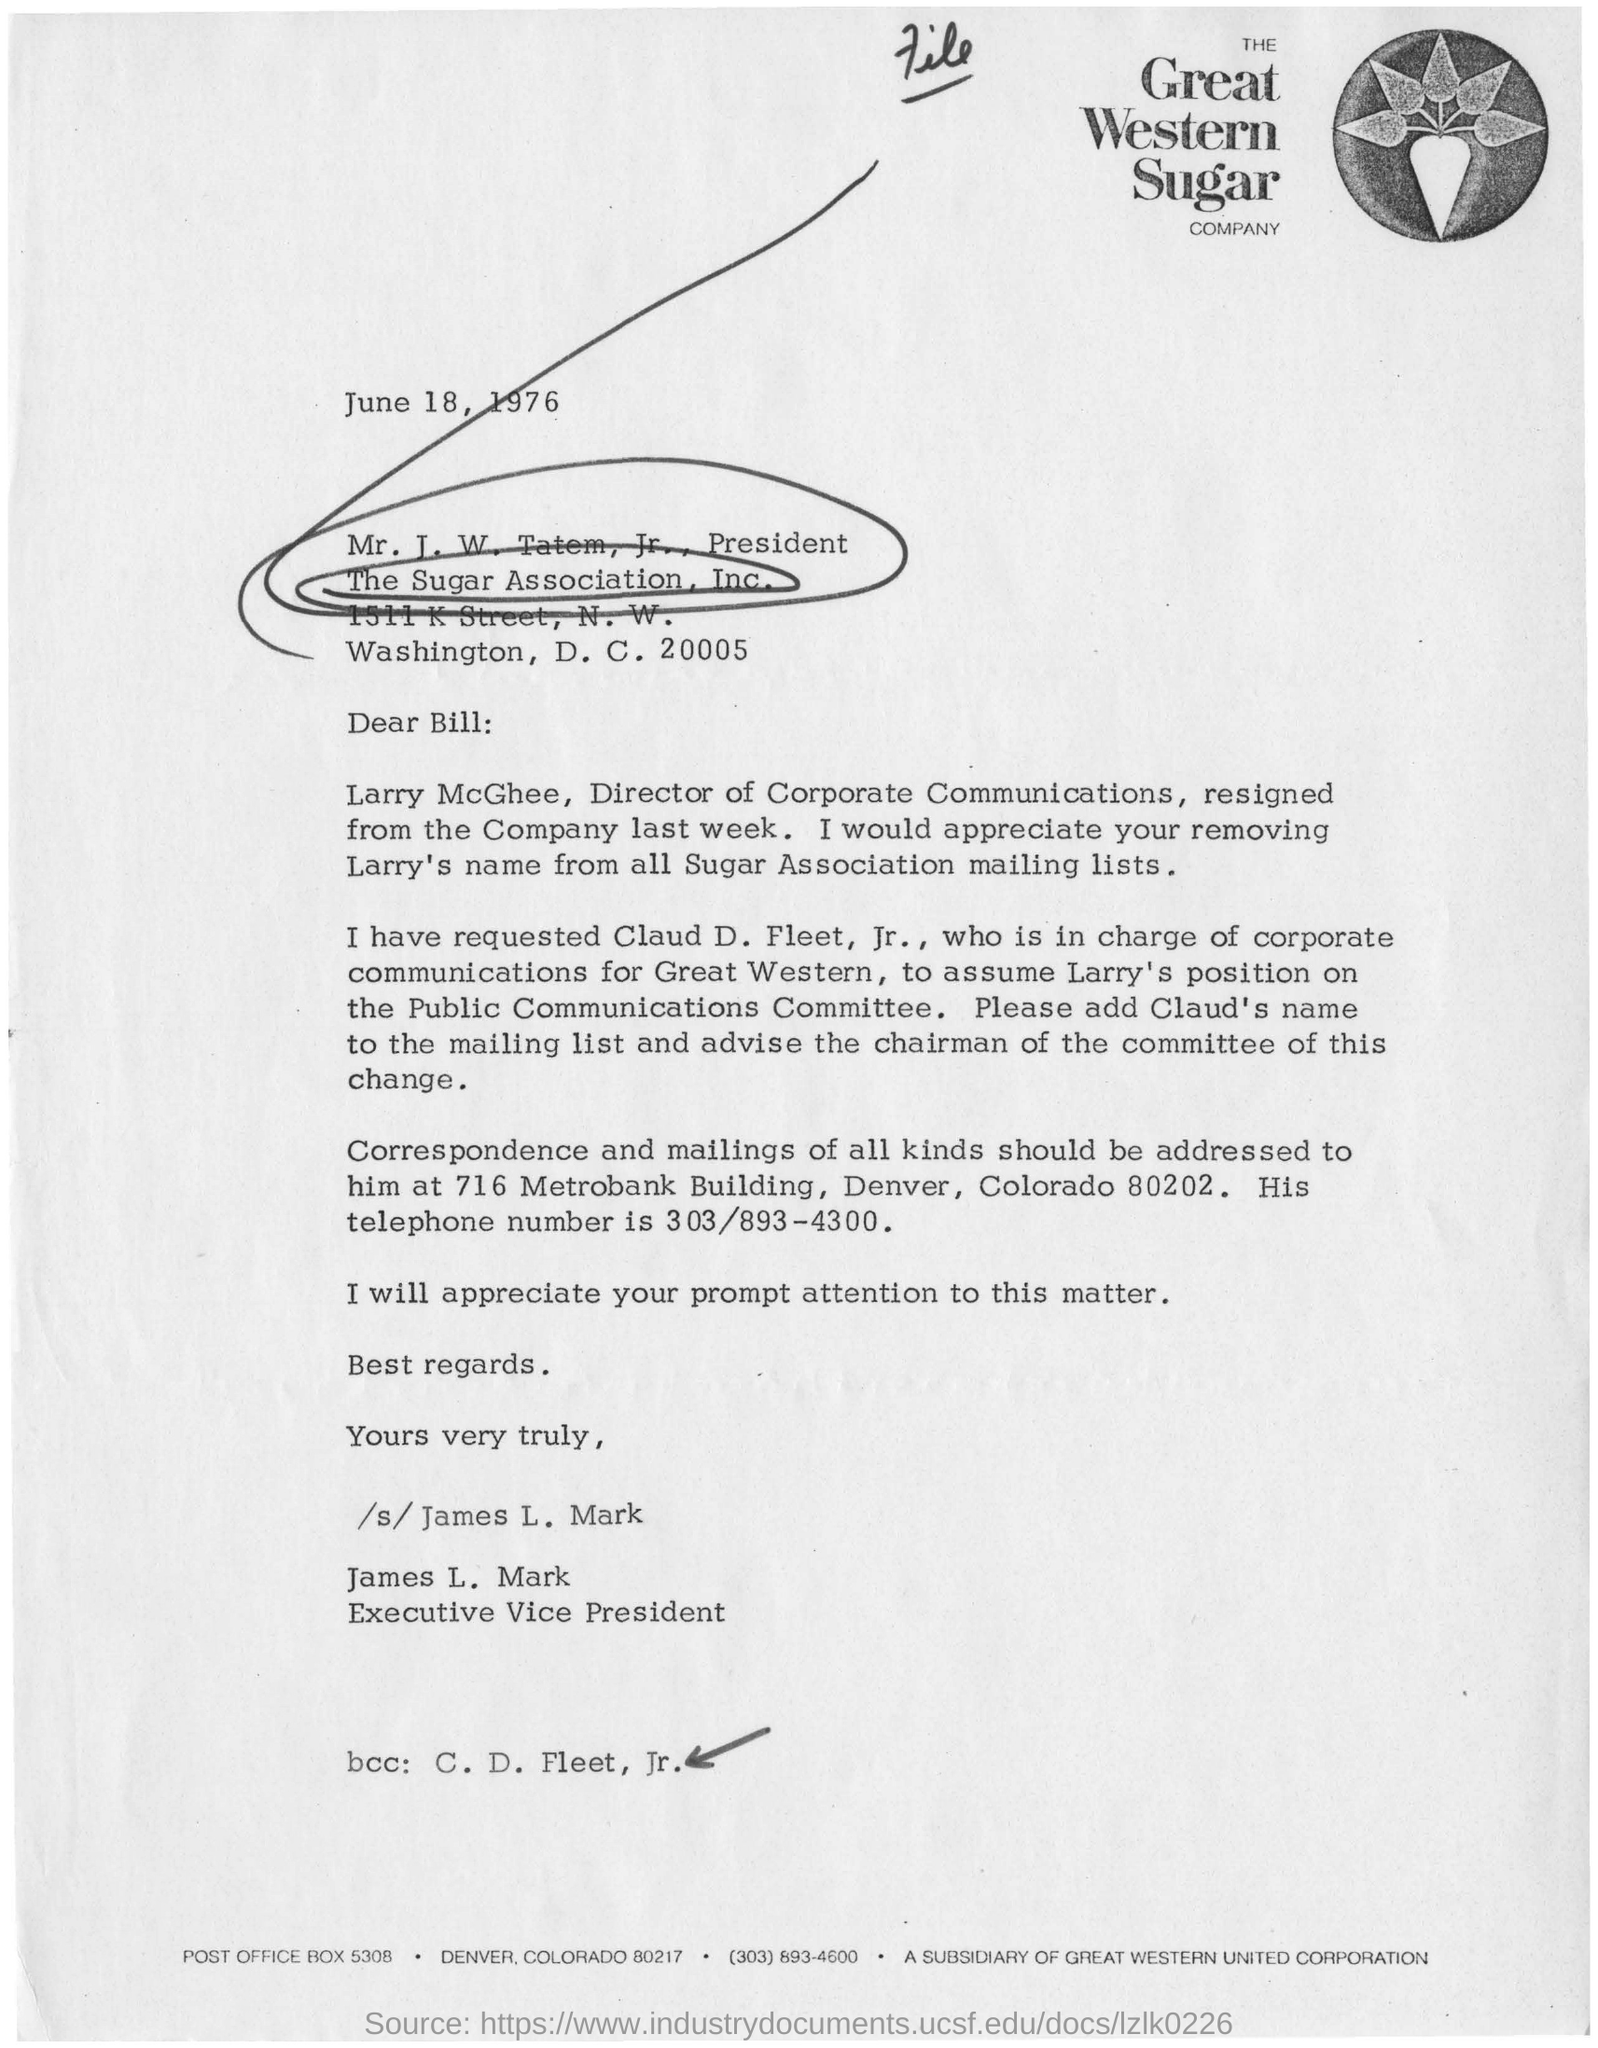What is the designation of James L. Mark?
Give a very brief answer. Executive Vice President. Which company is mentioned in the letterhead?
Keep it short and to the point. The Great Western Sugar Company. What is the date mentioned in the letter?
Provide a short and direct response. June 18, 1976. Who is the director of corporate communication ?
Give a very brief answer. Larry McGhee. 